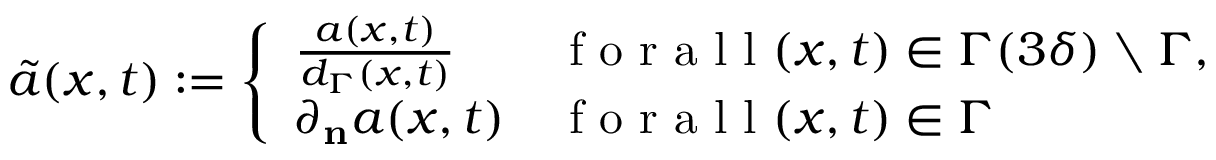<formula> <loc_0><loc_0><loc_500><loc_500>\tilde { a } ( x , t ) \colon = \left \{ \begin{array} { l l } { \frac { a ( x , t ) } { d _ { \Gamma } ( x , t ) } } & { f o r a l l ( x , t ) \in \Gamma ( 3 \delta ) \ \Gamma , } \\ { \partial _ { n } a ( x , t ) } & { f o r a l l ( x , t ) \in \Gamma } \end{array}</formula> 